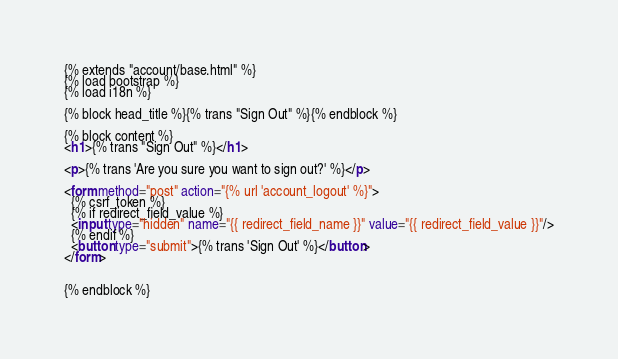Convert code to text. <code><loc_0><loc_0><loc_500><loc_500><_HTML_>{% extends "account/base.html" %}
{% load bootstrap %}
{% load i18n %}

{% block head_title %}{% trans "Sign Out" %}{% endblock %}

{% block content %}
<h1>{% trans "Sign Out" %}</h1>

<p>{% trans 'Are you sure you want to sign out?' %}</p>

<form method="post" action="{% url 'account_logout' %}">
  {% csrf_token %}
  {% if redirect_field_value %}
  <input type="hidden" name="{{ redirect_field_name }}" value="{{ redirect_field_value }}"/>
  {% endif %}
  <button type="submit">{% trans 'Sign Out' %}</button>
</form>


{% endblock %}
</code> 